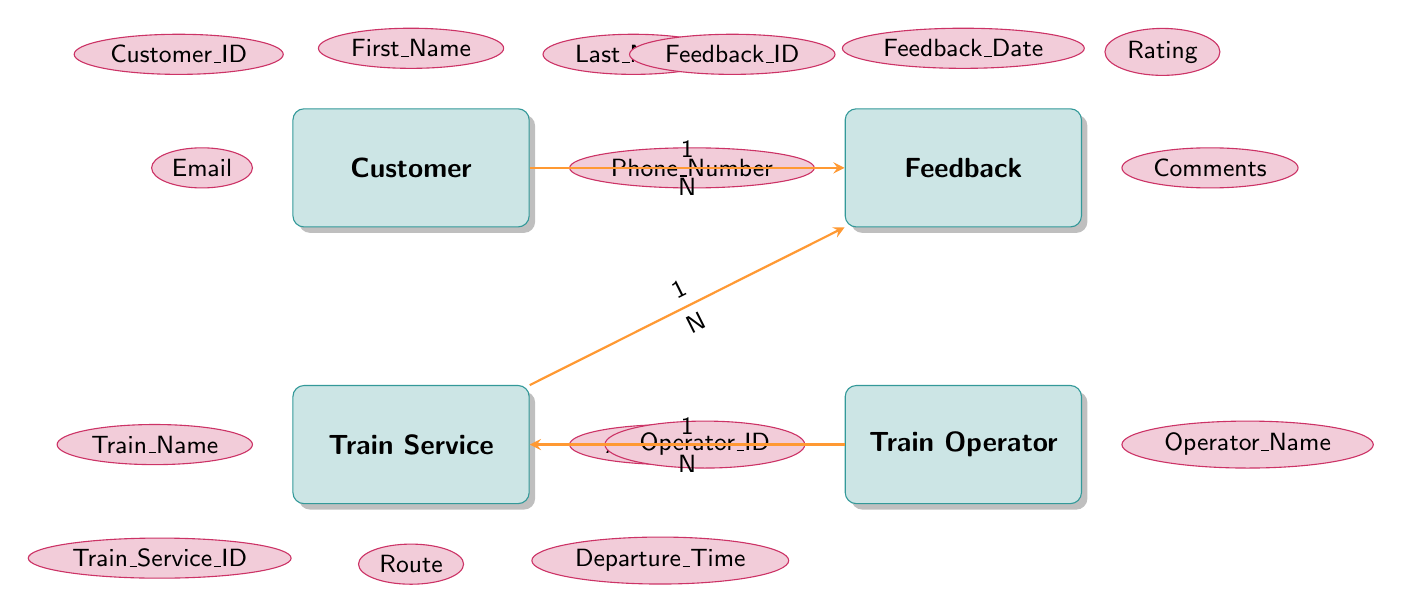What entities are present in the diagram? The diagram includes four entities: Customer, Feedback, Train Service, and Train Operator. These entities represent the key components of the Customer Feedback and Review System for Train Travel.
Answer: Customer, Feedback, Train Service, Train Operator How many attributes does the Feedback entity have? By examining the Feedback entity in the diagram, we can see it has four attributes: Feedback_ID, Feedback_Date, Rating, and Comments. Therefore, the total number of attributes for Feedback is four.
Answer: 4 What is the relationship type between Customer and Feedback? The relationship between Customer and Feedback is labeled as a "one-to-many" relationship, indicating that one customer can provide multiple feedback entries, but each feedback entry belongs to one customer.
Answer: one-to-many Can a Train Service have multiple Feedback entries? Yes, the diagram shows that Train Service has a one-to-many relationship with Feedback, meaning a single Train Service can receive multiple feedback entries from different customers.
Answer: Yes What connects Train Service to Train Operator? The Train Service is connected to the Train Operator through a one-to-many relationship, indicating that one Train Operator can operate multiple Train Services, but each Train Service is operated by one specific Train Operator.
Answer: one-to-many If a customer gives feedback, which entities are involved? When a customer gives feedback, both the Customer and Feedback entities are involved. The Customer provides the feedback, and the corresponding feedback record is created in the Feedback entity. Additionally, the Train Service entity might also be involved since feedback is often associated with a particular Train Service.
Answer: Customer, Feedback, Train Service What is the foreign key in the Feedback entity referencing the Customer entity? The foreign key in the Feedback entity referencing the Customer entity is Customer_ID. This key establishes the connection between the feedback provided and the specific customer who provided it.
Answer: Customer_ID How many relationships are depicted in the diagram? The diagram illustrates three relationships: one between Customer and Feedback, one between Train Service and Feedback, and one between Train Operator and Train Service. Therefore, the total number of relationships is three.
Answer: 3 Which entity has the attribute named Train_Name? The Train_Name attribute belongs to the Train Service entity, which includes various attributes relevant to railway services, including specific information about the train names.
Answer: Train Service 